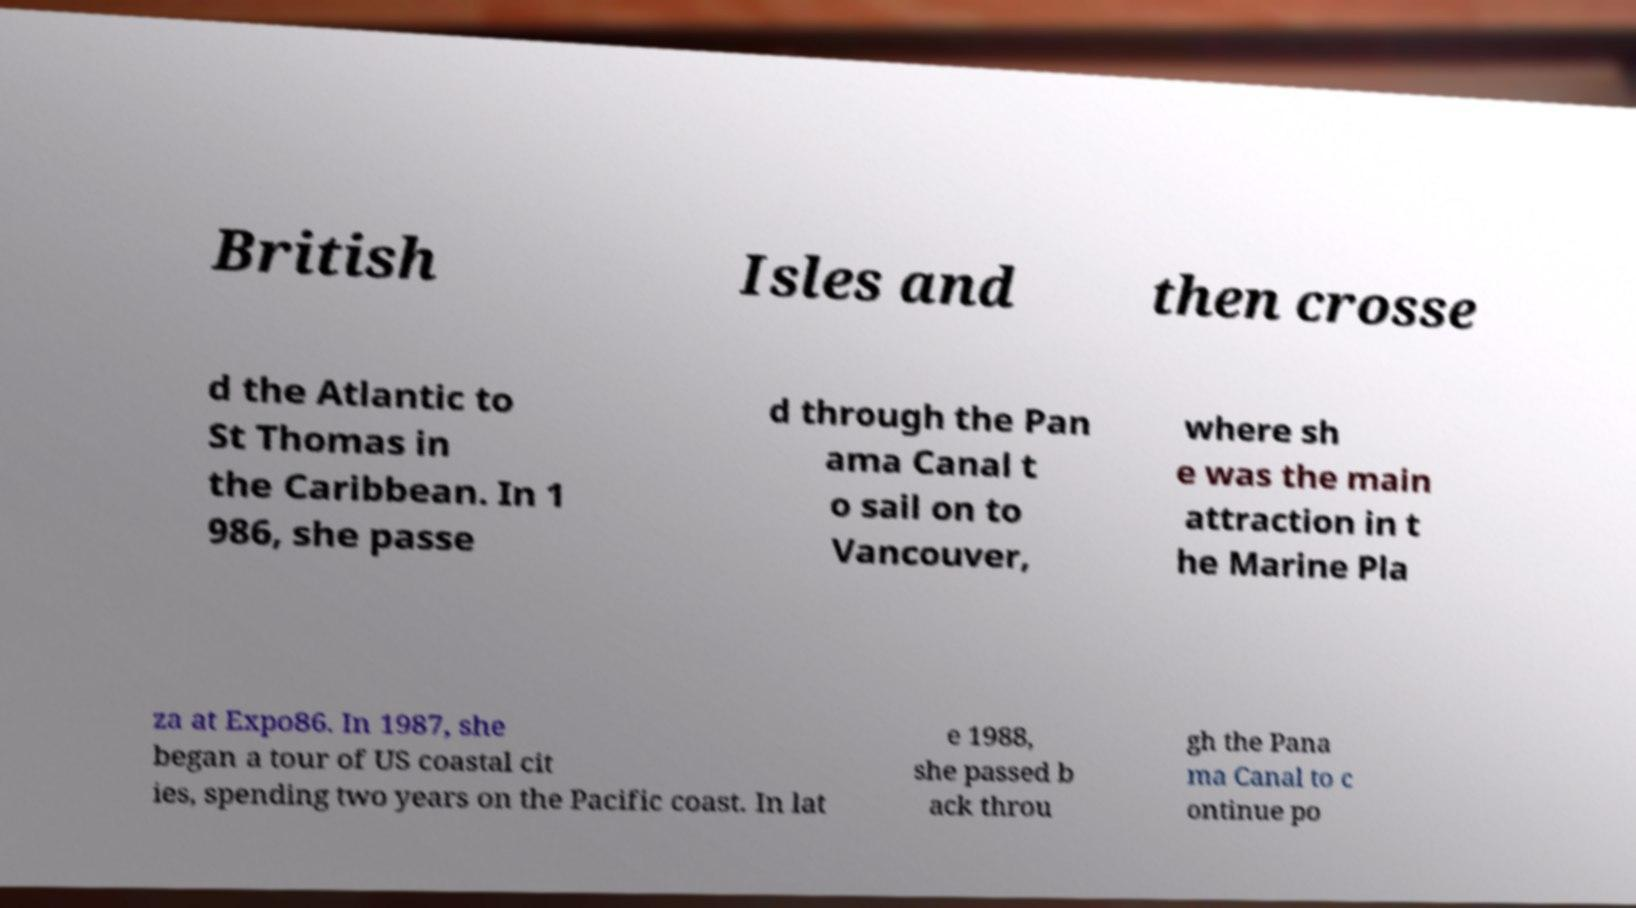For documentation purposes, I need the text within this image transcribed. Could you provide that? British Isles and then crosse d the Atlantic to St Thomas in the Caribbean. In 1 986, she passe d through the Pan ama Canal t o sail on to Vancouver, where sh e was the main attraction in t he Marine Pla za at Expo86. In 1987, she began a tour of US coastal cit ies, spending two years on the Pacific coast. In lat e 1988, she passed b ack throu gh the Pana ma Canal to c ontinue po 